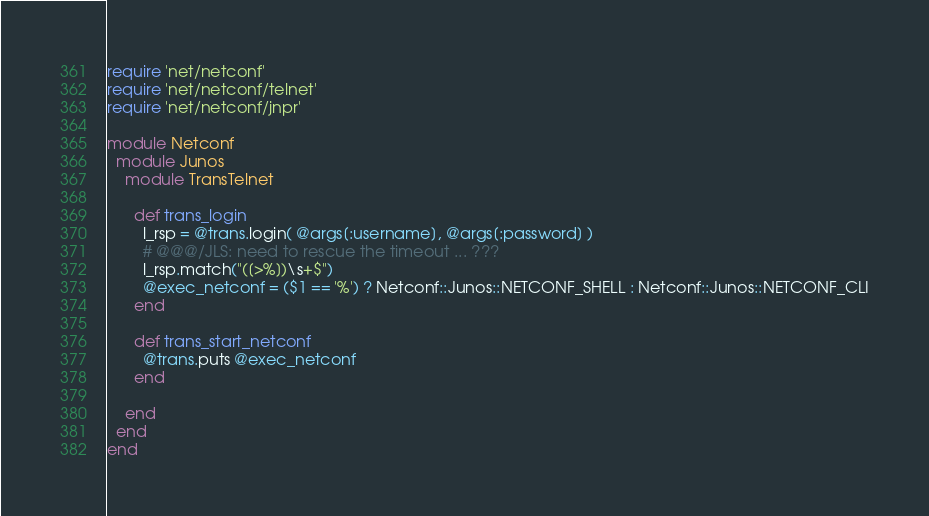Convert code to text. <code><loc_0><loc_0><loc_500><loc_500><_Ruby_>require 'net/netconf'
require 'net/netconf/telnet'
require 'net/netconf/jnpr'

module Netconf
  module Junos
    module TransTelnet

      def trans_login
        l_rsp = @trans.login( @args[:username], @args[:password] )
        # @@@/JLS: need to rescue the timeout ... ???
        l_rsp.match("([>%])\s+$")
        @exec_netconf = ($1 == '%') ? Netconf::Junos::NETCONF_SHELL : Netconf::Junos::NETCONF_CLI
      end

      def trans_start_netconf
        @trans.puts @exec_netconf
      end

    end
  end
end

</code> 